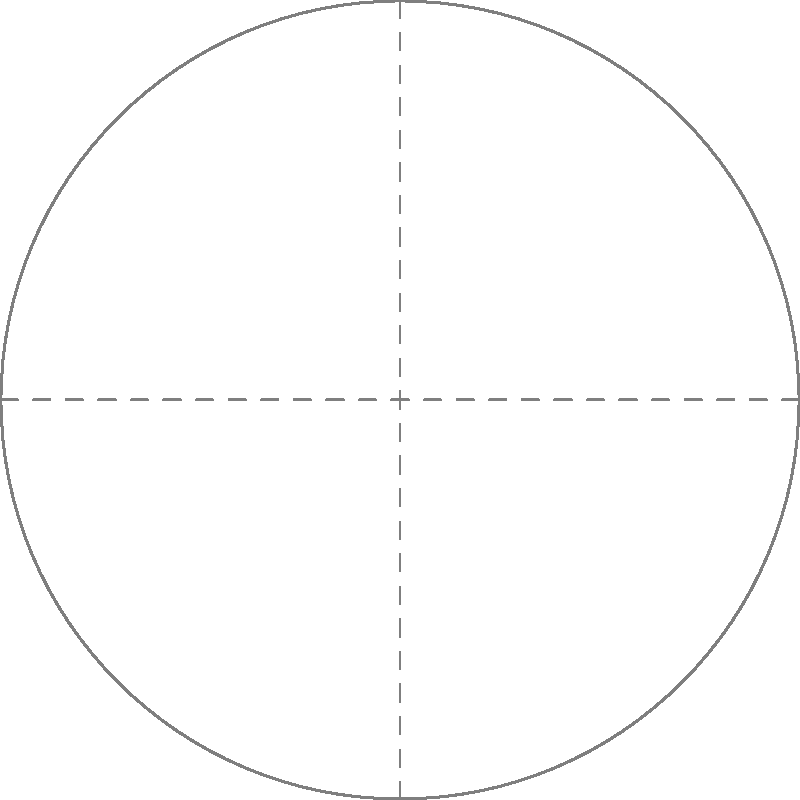During summer and winter in Bangladesh, the sun's position at noon forms different angles with respect to the horizon. If the angle between the sun's noon position in summer and winter is represented by $\theta$ in the diagram, what is the approximate value of $\theta$ in degrees? To find the angle $\theta$, we need to consider the following steps:

1. Bangladesh is located approximately at latitude 24°N.

2. The Earth's axial tilt is about 23.5°.

3. During summer solstice (around June 21):
   - The sun is directly overhead at 23.5°N latitude.
   - For Bangladesh (24°N), the sun's angle from zenith ≈ 24° - 23.5° = 0.5°
   - The sun's angle from horizon ≈ 90° - 0.5° = 89.5°

4. During winter solstice (around December 21):
   - The sun is directly overhead at 23.5°S latitude.
   - For Bangladesh (24°N), the sun's angle from zenith ≈ 24° + 23.5° = 47.5°
   - The sun's angle from horizon ≈ 90° - 47.5° = 42.5°

5. The difference between summer and winter angles:
   $\theta \approx 89.5° - 42.5° = 47°$

Therefore, the approximate value of $\theta$ is 47°.
Answer: 47° 